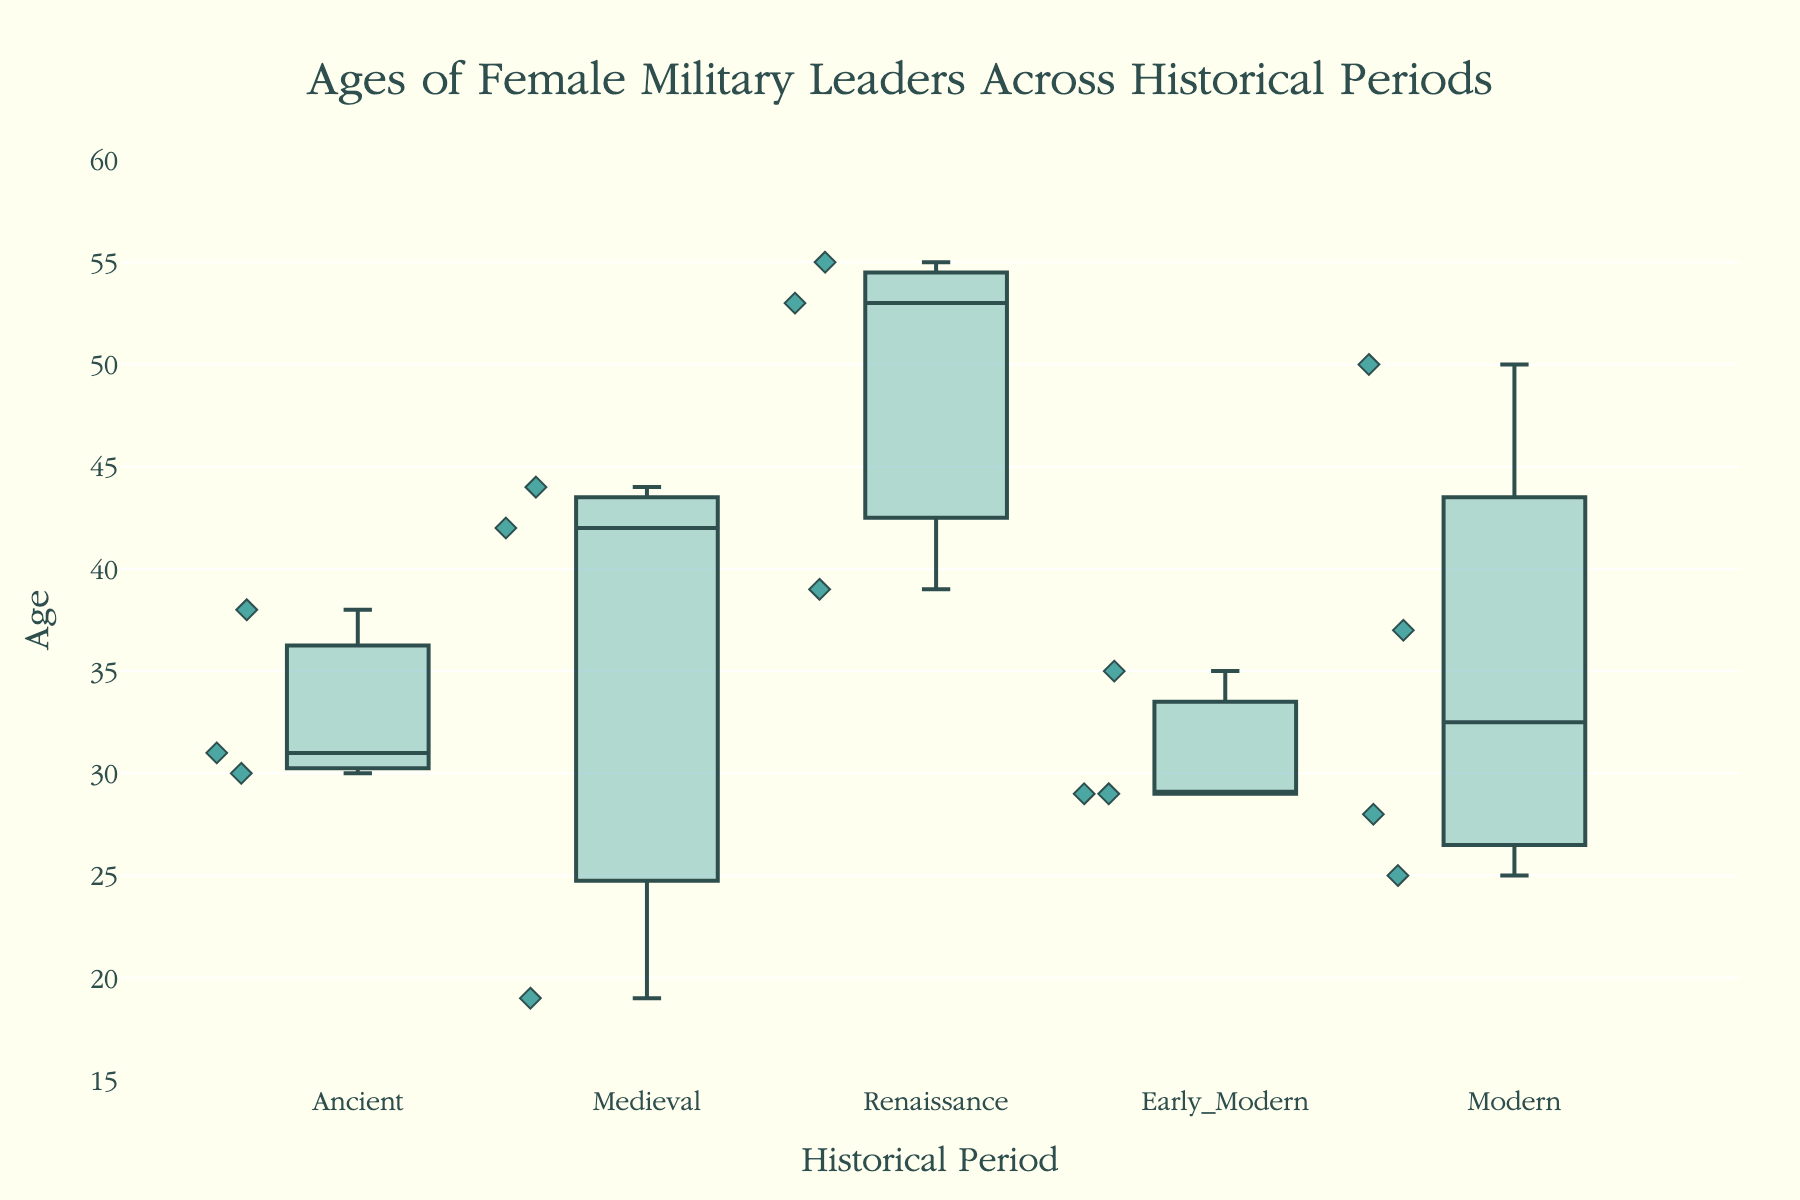What's the title of the plot? The title is located at the top center of the plot. It provides an immediate overview of what the data will represent.
Answer: Ages of Female Military Leaders Across Historical Periods Which historical period has the youngest median age of female military leaders? To find the youngest median age, look for the median line within each box. Identify the period with the lowest median line position on the y-axis.
Answer: Medieval What is the age range (difference between maximum and minimum values) of female military leaders in the Medieval period? Check the top and bottom of the whiskers for the Medieval box. The top whisker represents the maximum age and the bottom whisker the minimum age. Subtract the minimum from the maximum.
Answer: 44 - 19 = 25 How does the median age of female military leaders in the Early Modern period compare to those in the Renaissance period? Compare the horizontal lines inside the boxes for the Early Modern and Renaissance periods. Determine if the Early Modern line is higher, lower, or at the same level as the Renaissance line.
Answer: Lower Which historical period has the widest interquartile range (IQR) of ages? The IQR is the distance between the first quartile (bottom of the box) and the third quartile (top of the box). Compare the height of the boxes across periods to find the widest one.
Answer: Early Modern Who is the oldest female military leader in the Modern period based on the plot? Look at the points above the top whisker in the Modern period box. The hovertext (if it were interactive) or the points themselves identify the leader's name.
Answer: Nickey Haley Is there any historical period where all the ages of female military leaders are below 40? Check each period’s whiskers and data points. Identify if any period’s maximum age does not exceed 40.
Answer: Medieval Which period has the smallest age range? Compare the distances between the whiskers for each period to identify the smallest range.
Answer: Modern What does the height of the boxes represent in the plot? Each box’s height represents the interquartile range (IQR), which is the spread of the middle 50% of the data points, situated between the first and third quartiles.
Answer: Interquartile range (IQR) Are there any outliers among the ages of female military leaders? If so, identify the period they belong to. Outliers are represented by individual points outside the whiskers. Spot any such points and note the associated period.
Answer: Yes, each period except Modern has outliers 